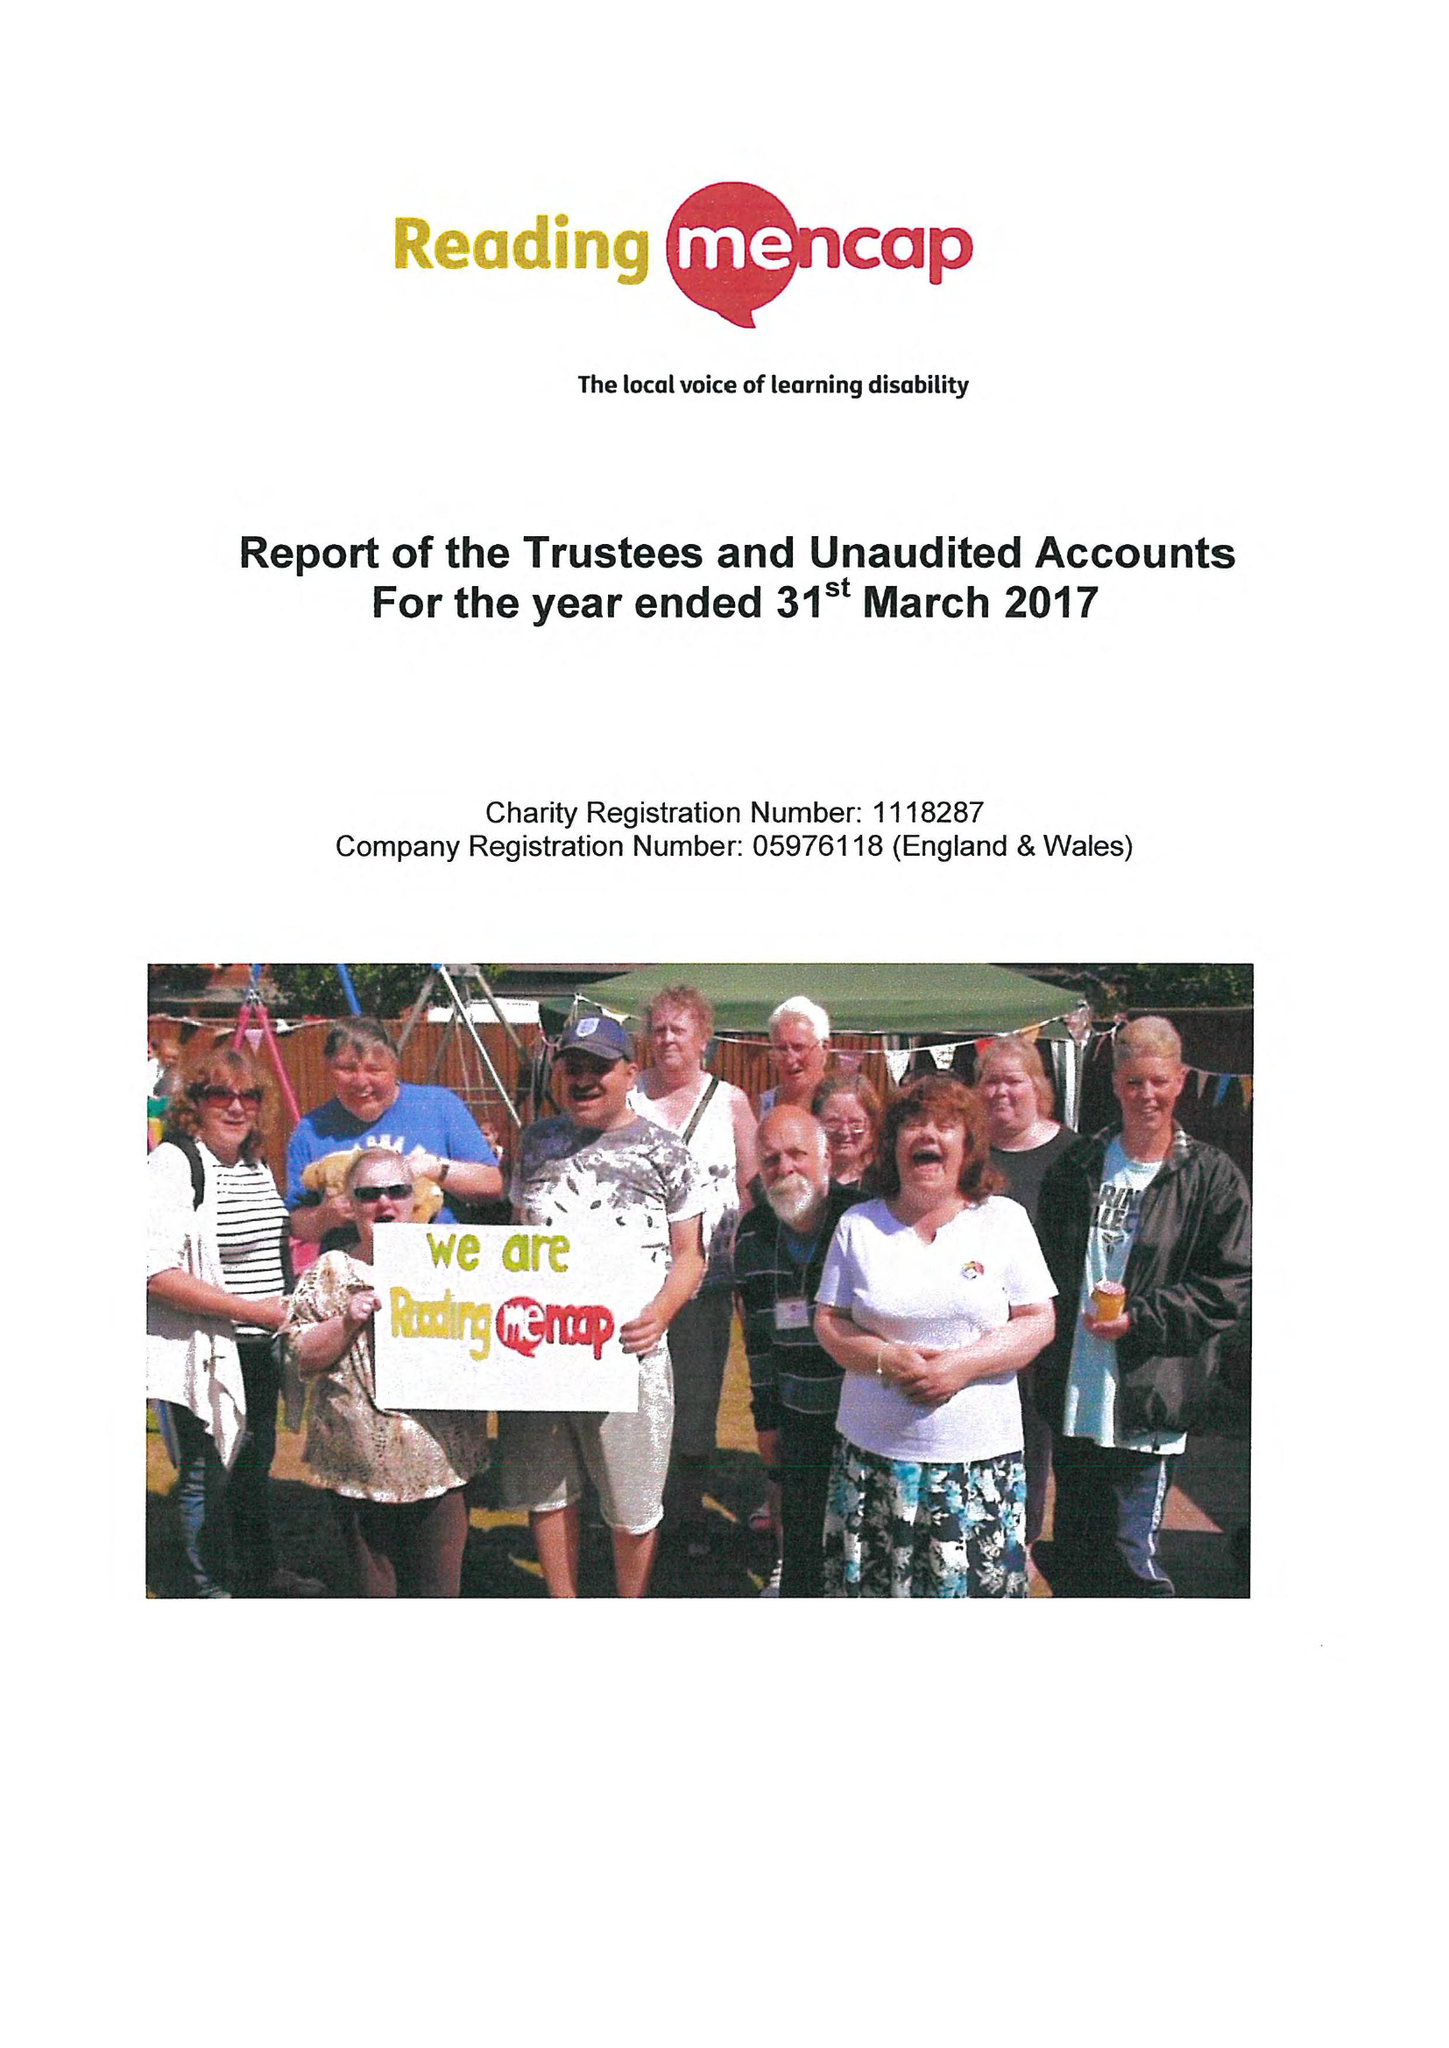What is the value for the address__post_town?
Answer the question using a single word or phrase. READING 